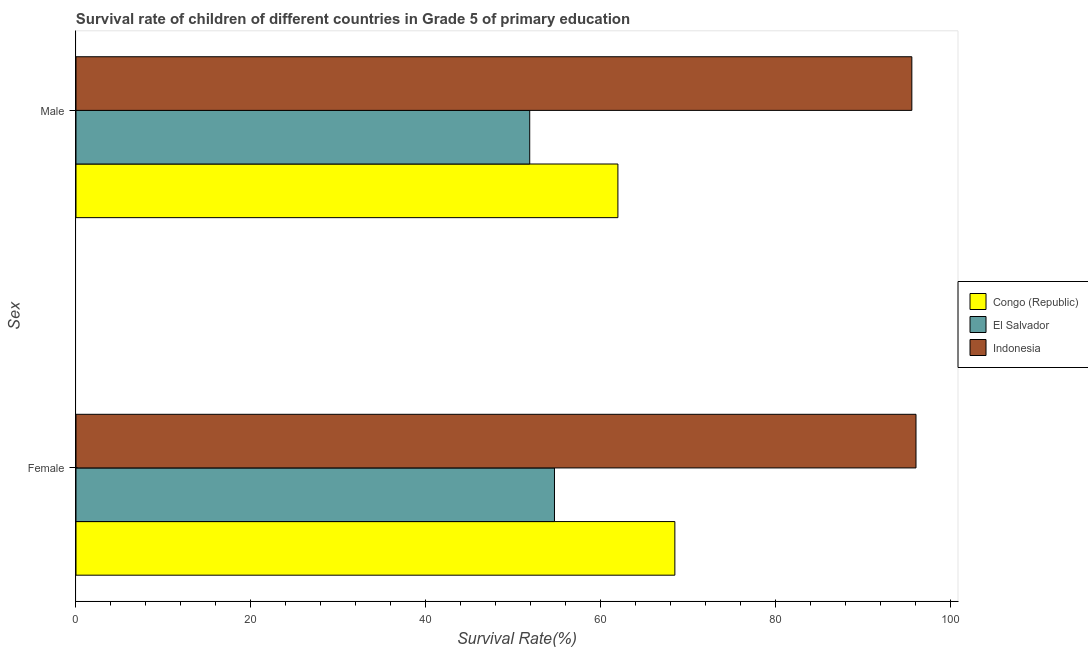What is the survival rate of female students in primary education in El Salvador?
Offer a very short reply. 54.72. Across all countries, what is the maximum survival rate of male students in primary education?
Offer a very short reply. 95.6. Across all countries, what is the minimum survival rate of female students in primary education?
Ensure brevity in your answer.  54.72. In which country was the survival rate of female students in primary education minimum?
Provide a succinct answer. El Salvador. What is the total survival rate of male students in primary education in the graph?
Offer a very short reply. 209.47. What is the difference between the survival rate of male students in primary education in El Salvador and that in Indonesia?
Ensure brevity in your answer.  -43.7. What is the difference between the survival rate of female students in primary education in Indonesia and the survival rate of male students in primary education in Congo (Republic)?
Your response must be concise. 34.09. What is the average survival rate of male students in primary education per country?
Your response must be concise. 69.82. What is the difference between the survival rate of female students in primary education and survival rate of male students in primary education in Indonesia?
Make the answer very short. 0.48. What is the ratio of the survival rate of male students in primary education in El Salvador to that in Congo (Republic)?
Keep it short and to the point. 0.84. Is the survival rate of female students in primary education in Indonesia less than that in El Salvador?
Make the answer very short. No. In how many countries, is the survival rate of female students in primary education greater than the average survival rate of female students in primary education taken over all countries?
Your answer should be compact. 1. What does the 3rd bar from the top in Male represents?
Your answer should be compact. Congo (Republic). What is the difference between two consecutive major ticks on the X-axis?
Make the answer very short. 20. Does the graph contain grids?
Keep it short and to the point. No. How many legend labels are there?
Give a very brief answer. 3. What is the title of the graph?
Provide a succinct answer. Survival rate of children of different countries in Grade 5 of primary education. What is the label or title of the X-axis?
Provide a short and direct response. Survival Rate(%). What is the label or title of the Y-axis?
Offer a very short reply. Sex. What is the Survival Rate(%) of Congo (Republic) in Female?
Provide a short and direct response. 68.49. What is the Survival Rate(%) in El Salvador in Female?
Offer a terse response. 54.72. What is the Survival Rate(%) of Indonesia in Female?
Your answer should be compact. 96.07. What is the Survival Rate(%) of Congo (Republic) in Male?
Your answer should be very brief. 61.98. What is the Survival Rate(%) of El Salvador in Male?
Ensure brevity in your answer.  51.89. What is the Survival Rate(%) in Indonesia in Male?
Your answer should be compact. 95.6. Across all Sex, what is the maximum Survival Rate(%) of Congo (Republic)?
Offer a terse response. 68.49. Across all Sex, what is the maximum Survival Rate(%) in El Salvador?
Your response must be concise. 54.72. Across all Sex, what is the maximum Survival Rate(%) of Indonesia?
Give a very brief answer. 96.07. Across all Sex, what is the minimum Survival Rate(%) in Congo (Republic)?
Your response must be concise. 61.98. Across all Sex, what is the minimum Survival Rate(%) in El Salvador?
Make the answer very short. 51.89. Across all Sex, what is the minimum Survival Rate(%) in Indonesia?
Your answer should be compact. 95.6. What is the total Survival Rate(%) of Congo (Republic) in the graph?
Give a very brief answer. 130.47. What is the total Survival Rate(%) of El Salvador in the graph?
Make the answer very short. 106.62. What is the total Survival Rate(%) in Indonesia in the graph?
Your response must be concise. 191.67. What is the difference between the Survival Rate(%) in Congo (Republic) in Female and that in Male?
Your response must be concise. 6.51. What is the difference between the Survival Rate(%) in El Salvador in Female and that in Male?
Keep it short and to the point. 2.83. What is the difference between the Survival Rate(%) of Indonesia in Female and that in Male?
Offer a terse response. 0.48. What is the difference between the Survival Rate(%) in Congo (Republic) in Female and the Survival Rate(%) in El Salvador in Male?
Provide a succinct answer. 16.6. What is the difference between the Survival Rate(%) in Congo (Republic) in Female and the Survival Rate(%) in Indonesia in Male?
Your response must be concise. -27.1. What is the difference between the Survival Rate(%) in El Salvador in Female and the Survival Rate(%) in Indonesia in Male?
Provide a short and direct response. -40.87. What is the average Survival Rate(%) of Congo (Republic) per Sex?
Provide a succinct answer. 65.24. What is the average Survival Rate(%) of El Salvador per Sex?
Make the answer very short. 53.31. What is the average Survival Rate(%) in Indonesia per Sex?
Provide a succinct answer. 95.84. What is the difference between the Survival Rate(%) in Congo (Republic) and Survival Rate(%) in El Salvador in Female?
Keep it short and to the point. 13.77. What is the difference between the Survival Rate(%) in Congo (Republic) and Survival Rate(%) in Indonesia in Female?
Provide a short and direct response. -27.58. What is the difference between the Survival Rate(%) in El Salvador and Survival Rate(%) in Indonesia in Female?
Your answer should be compact. -41.35. What is the difference between the Survival Rate(%) in Congo (Republic) and Survival Rate(%) in El Salvador in Male?
Offer a very short reply. 10.09. What is the difference between the Survival Rate(%) in Congo (Republic) and Survival Rate(%) in Indonesia in Male?
Keep it short and to the point. -33.62. What is the difference between the Survival Rate(%) in El Salvador and Survival Rate(%) in Indonesia in Male?
Provide a short and direct response. -43.7. What is the ratio of the Survival Rate(%) of Congo (Republic) in Female to that in Male?
Offer a very short reply. 1.11. What is the ratio of the Survival Rate(%) of El Salvador in Female to that in Male?
Provide a succinct answer. 1.05. What is the difference between the highest and the second highest Survival Rate(%) of Congo (Republic)?
Provide a short and direct response. 6.51. What is the difference between the highest and the second highest Survival Rate(%) of El Salvador?
Ensure brevity in your answer.  2.83. What is the difference between the highest and the second highest Survival Rate(%) in Indonesia?
Provide a succinct answer. 0.48. What is the difference between the highest and the lowest Survival Rate(%) of Congo (Republic)?
Ensure brevity in your answer.  6.51. What is the difference between the highest and the lowest Survival Rate(%) in El Salvador?
Ensure brevity in your answer.  2.83. What is the difference between the highest and the lowest Survival Rate(%) in Indonesia?
Offer a very short reply. 0.48. 